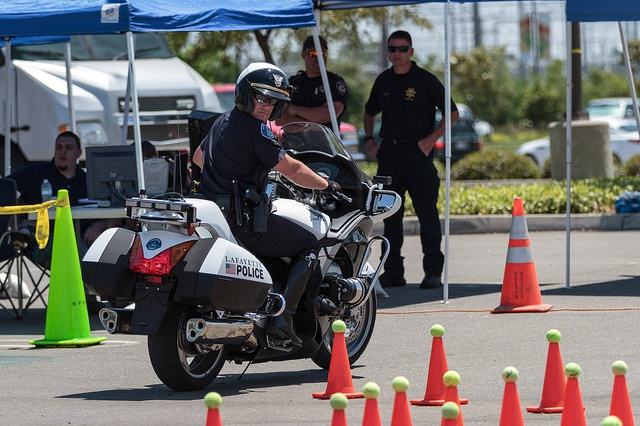Describe the objects in this image and their specific colors. I can see motorcycle in lightblue, black, gray, darkgray, and lightgray tones, truck in lightblue, gray, lightgray, and darkgray tones, people in lightblue, black, gray, brown, and navy tones, people in lightblue, black, maroon, gray, and darkgray tones, and people in lightblue, black, and gray tones in this image. 